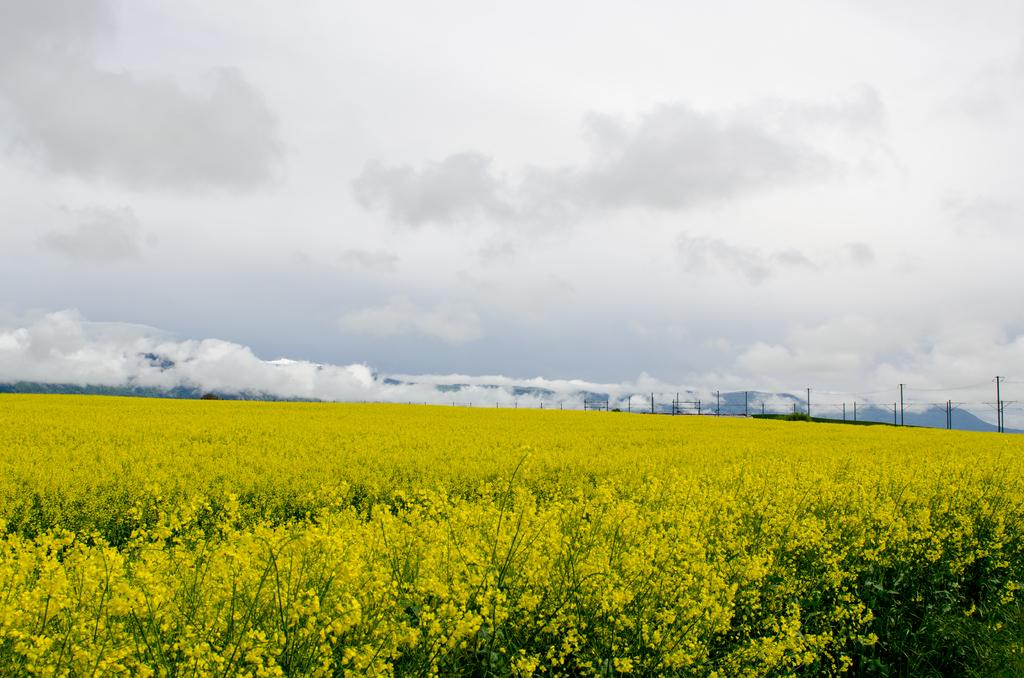What color are the plants on the ground in the image? The plants on the ground are yellow in color. What else can be seen in the image besides the plants? There are some poles in the image. What is visible in the background of the image? There is a sky visible in the background of the image. What can be observed in the sky? There are clouds in the sky. Can you tell me how many times the person sneezed while taking the picture? There is no person present in the image, and therefore no sneezing can be observed. What type of fork is being used to pick up the clouds in the sky? There is no fork present in the image, and the image does not depict anyone interacting with the clouds. 